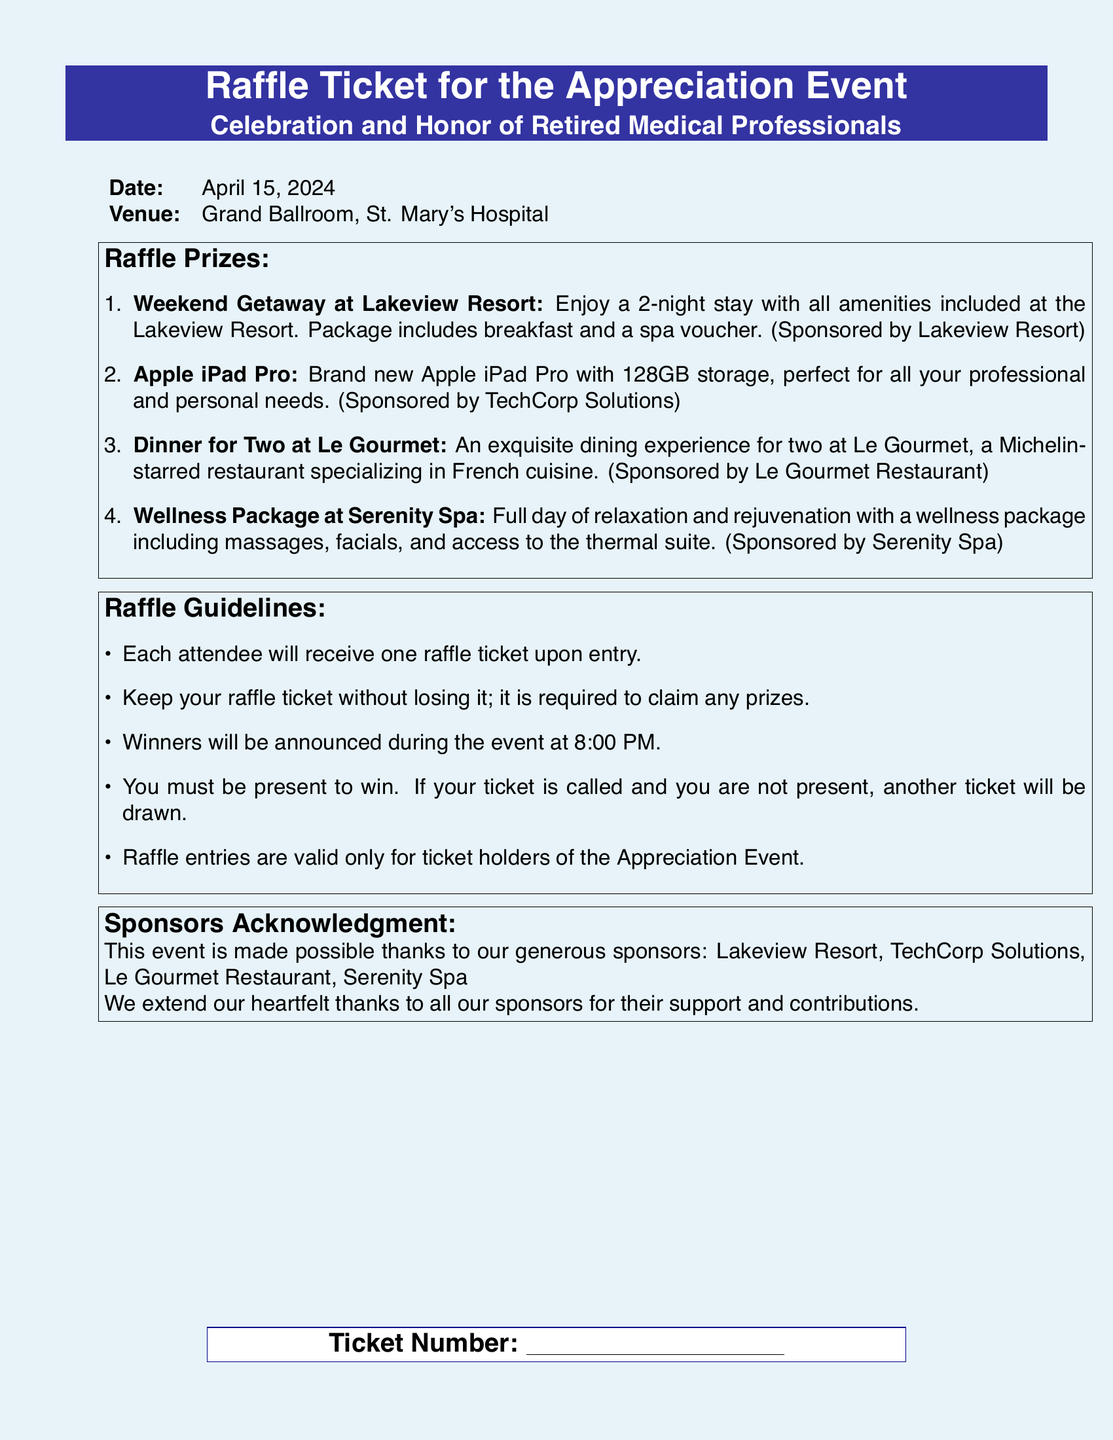What date is the Appreciation Event? The event date is explicitly stated in the document as April 15, 2024.
Answer: April 15, 2024 Where is the venue for the event? The venue for the event is clearly mentioned in the document as the Grand Ballroom, St. Mary's Hospital.
Answer: Grand Ballroom, St. Mary's Hospital What is one of the raffle prizes? Several raffle prizes are listed; one example is the Weekend Getaway at Lakeview Resort.
Answer: Weekend Getaway at Lakeview Resort When will the winners be announced? The document specifies that the winners will be announced during the event at 8:00 PM.
Answer: 8:00 PM How many raffle tickets does each attendee receive? The document states that each attendee will receive one raffle ticket upon entry.
Answer: One raffle ticket What happens if a winner is not present at the time of the drawing? The document explains that if a winner is not present, another ticket will be drawn.
Answer: Another ticket will be drawn Who is sponsoring the Apple iPad Pro? The sponsorship information in the document identifies TechCorp Solutions as the sponsor for the Apple iPad Pro.
Answer: TechCorp Solutions What type of restaurant is Le Gourmet? The document describes Le Gourmet as a Michelin-starred restaurant specializing in French cuisine.
Answer: Michelin-starred French cuisine What must attendees do to claim their prizes? The document indicates that attendees must keep their raffle ticket to claim any prizes.
Answer: Keep their raffle ticket 